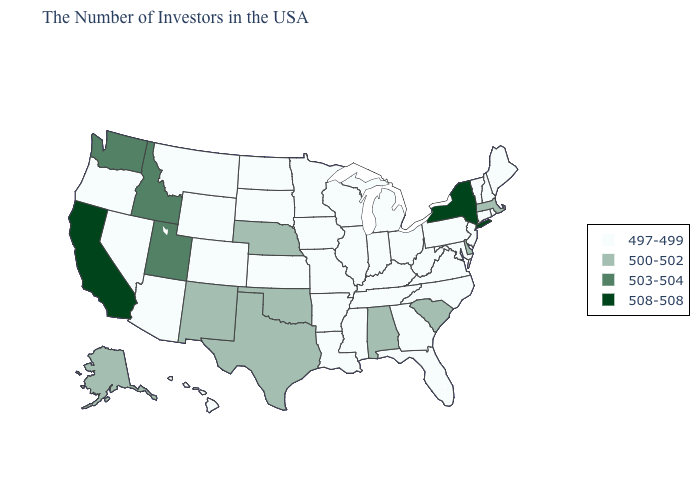Which states have the lowest value in the USA?
Quick response, please. Maine, Rhode Island, New Hampshire, Vermont, Connecticut, New Jersey, Maryland, Pennsylvania, Virginia, North Carolina, West Virginia, Ohio, Florida, Georgia, Michigan, Kentucky, Indiana, Tennessee, Wisconsin, Illinois, Mississippi, Louisiana, Missouri, Arkansas, Minnesota, Iowa, Kansas, South Dakota, North Dakota, Wyoming, Colorado, Montana, Arizona, Nevada, Oregon, Hawaii. Which states have the highest value in the USA?
Concise answer only. New York, California. What is the value of Alabama?
Give a very brief answer. 500-502. Does Alabama have the highest value in the USA?
Give a very brief answer. No. What is the value of Kentucky?
Answer briefly. 497-499. Which states have the highest value in the USA?
Write a very short answer. New York, California. Name the states that have a value in the range 508-508?
Write a very short answer. New York, California. Which states have the lowest value in the West?
Give a very brief answer. Wyoming, Colorado, Montana, Arizona, Nevada, Oregon, Hawaii. What is the value of Montana?
Keep it brief. 497-499. Does Rhode Island have a lower value than Idaho?
Quick response, please. Yes. What is the highest value in the West ?
Be succinct. 508-508. Which states have the highest value in the USA?
Give a very brief answer. New York, California. Name the states that have a value in the range 503-504?
Be succinct. Utah, Idaho, Washington. 